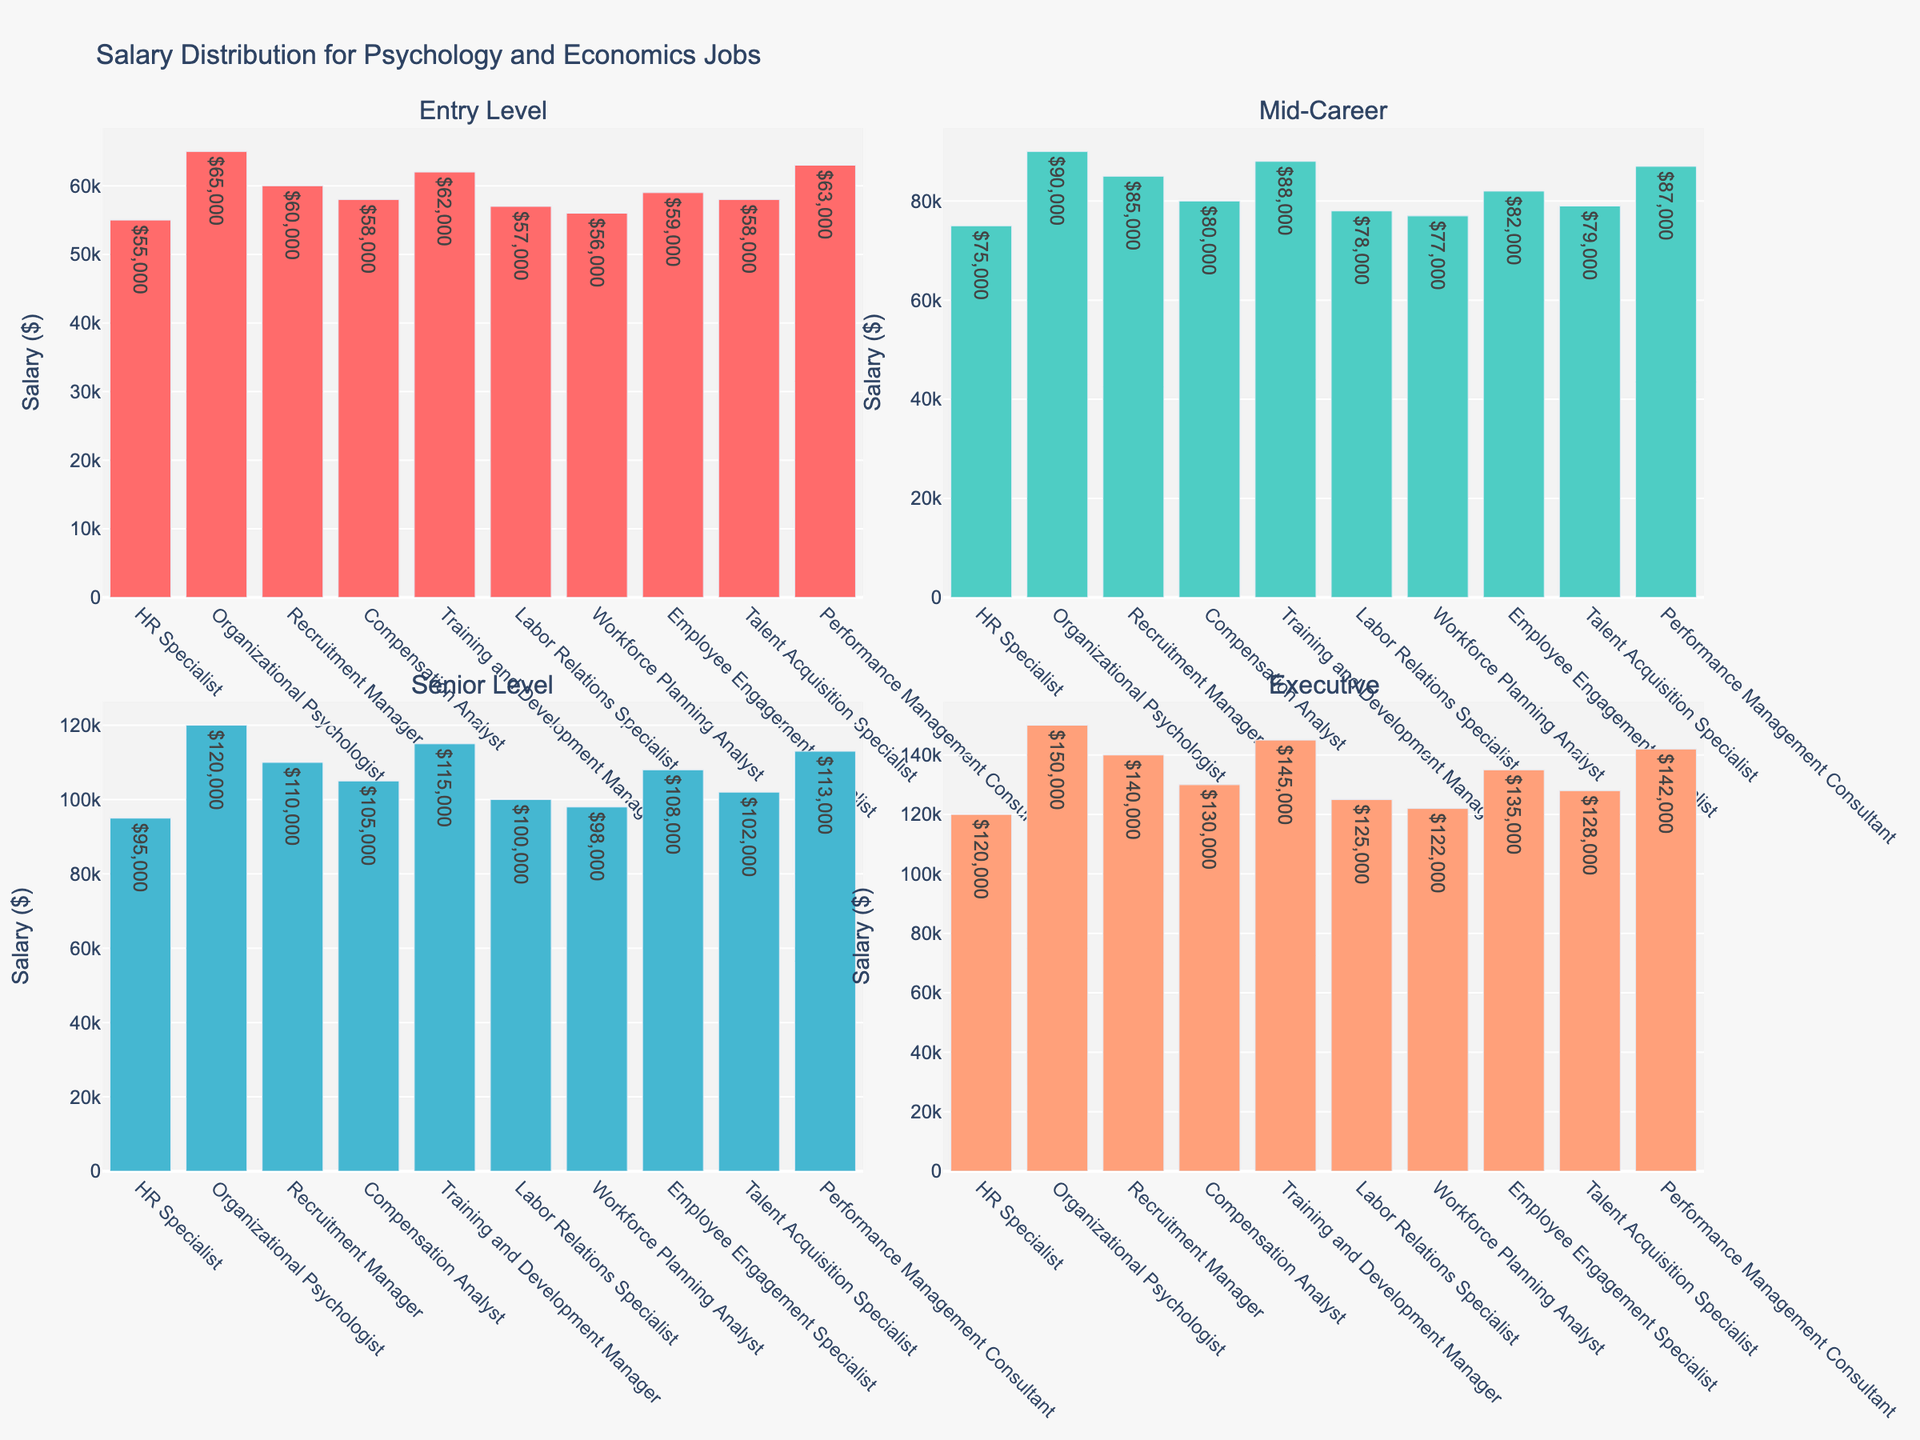What is the title of the figure? The title is positioned at the top of the plot and often describes the content of the figure. It provides an overview of what the chart is depicting.
Answer: Distribution of Volunteer Hours for Church Activities How many activities are represented in the top 8 activities plot? The top 8 activities would be depicted in the first subplot according to the figure's arrangement. You need to count the number of bars in the top plot.
Answer: 8 Which activity has the highest number of volunteer hours? The activity with the longest bar in the entire figure represents the highest number of volunteer hours.
Answer: Worship Service What is the difference in volunteer hours between Worship Service and Administrative Support? Find the bar for Worship Service and note its length (120 hours). Then find the bar for Administrative Support and note its length (30 hours). Subtract the hours for Administrative Support from Worship Service.
Answer: 90 hours What is the range of volunteer hours for the bottom 7 activities? The range is found by subtracting the smallest value in the bottom 7 activities from the largest value in those activities. Identify these values from the bottom subplot (Counseling Services: 55 hours, Senior Fellowship: 35 hours).
Answer: 20 hours Which two activities have the closest number of volunteer hours in the bottom 7 activities? Compare the lengths of the bars in the bottom subplot to find the two activities with the smallest difference in hours.
Answer: Fundraising Events and Senior Fellowship How does the total volunteer hours for the top 8 activities compare to the bottom 7 activities? Add the hours from the top 8 activities and compare to the sum of the hours from the bottom 7 activities. Top 8 activities sum: 120 + 110 + 100 + 90 + 80 + 75 + 70 + 65 = 710 hours; Bottom 7 activities sum: 60 + 55 + 50 + 45 + 40 + 35 + 30 = 315 hours.
Answer: Top 8 activities have 395 more hours What is the average number of volunteer hours for the top 8 activities? Add the hours for the top 8 activities and then divide by the number of activities. (120 + 110 + 100 + 90 + 80 + 75 + 70 + 65)/8
Answer: 88.75 hours In the bottom 7 activities, which activity has the highest number of volunteer hours, and how much is it? Identify the activity with the longest bar in the bottom subplot and note the number of hours.
Answer: Counseling Services, 55 hours Which subplot has a wider range of volunteer hours? Compare the range of hours in the top 8 activities (120 - 65) and the bottom 7 activities (55 - 30).
Answer: The top 8 activities (55 hours) 